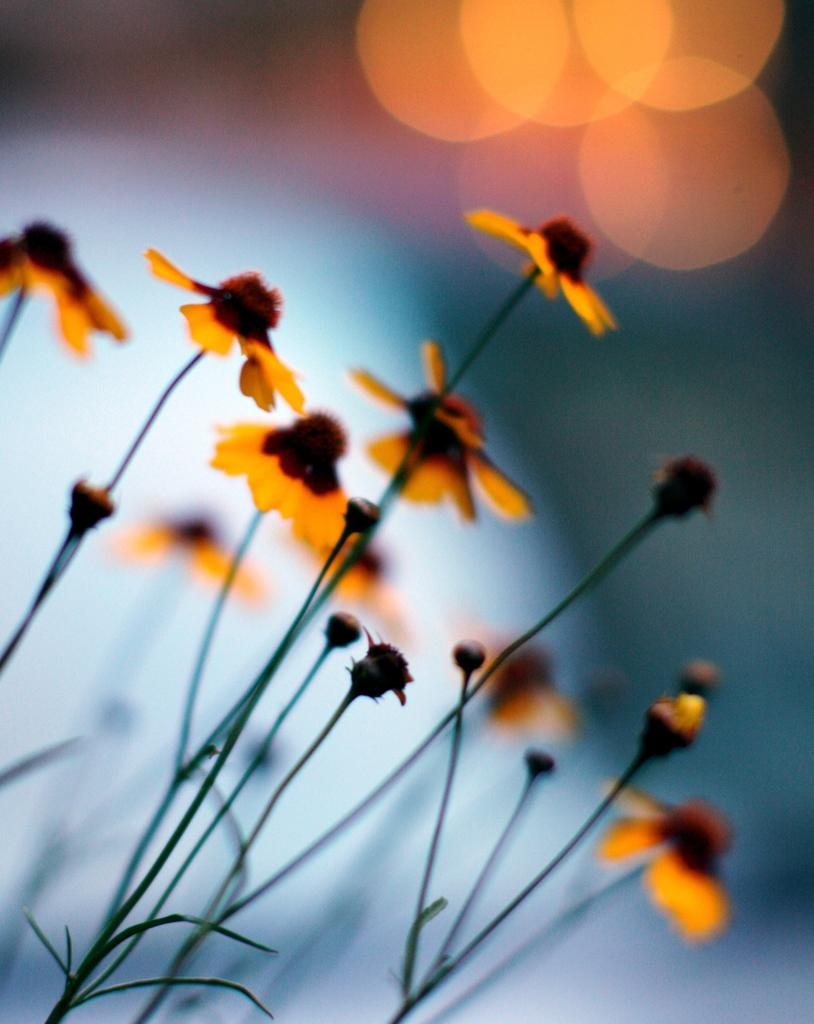What type of plant is visible in the image? There is a plant with small orange flowers in the image. Can you describe the background of the image? The background of the image is blurred. What type of power source is visible in the image? There is no power source visible in the image; it features a plant with small orange flowers and a blurred background. What type of pancake is being prepared in the image? There is no pancake or preparation of a pancake visible in the image. 